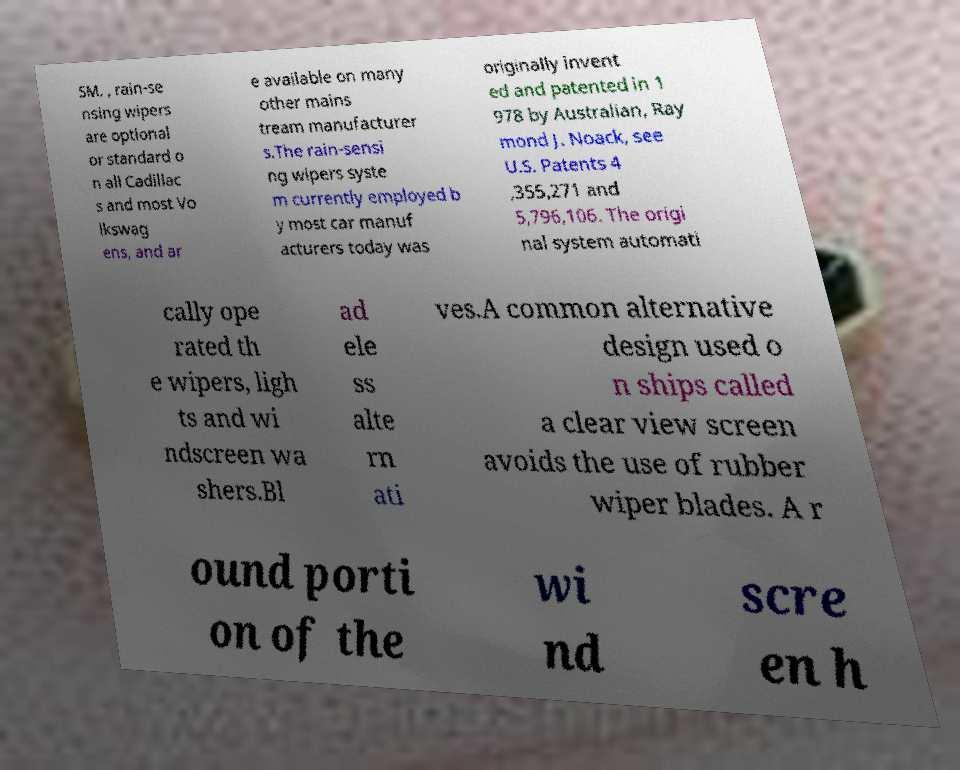For documentation purposes, I need the text within this image transcribed. Could you provide that? SM. , rain-se nsing wipers are optional or standard o n all Cadillac s and most Vo lkswag ens, and ar e available on many other mains tream manufacturer s.The rain-sensi ng wipers syste m currently employed b y most car manuf acturers today was originally invent ed and patented in 1 978 by Australian, Ray mond J. Noack, see U.S. Patents 4 ,355,271 and 5,796,106. The origi nal system automati cally ope rated th e wipers, ligh ts and wi ndscreen wa shers.Bl ad ele ss alte rn ati ves.A common alternative design used o n ships called a clear view screen avoids the use of rubber wiper blades. A r ound porti on of the wi nd scre en h 